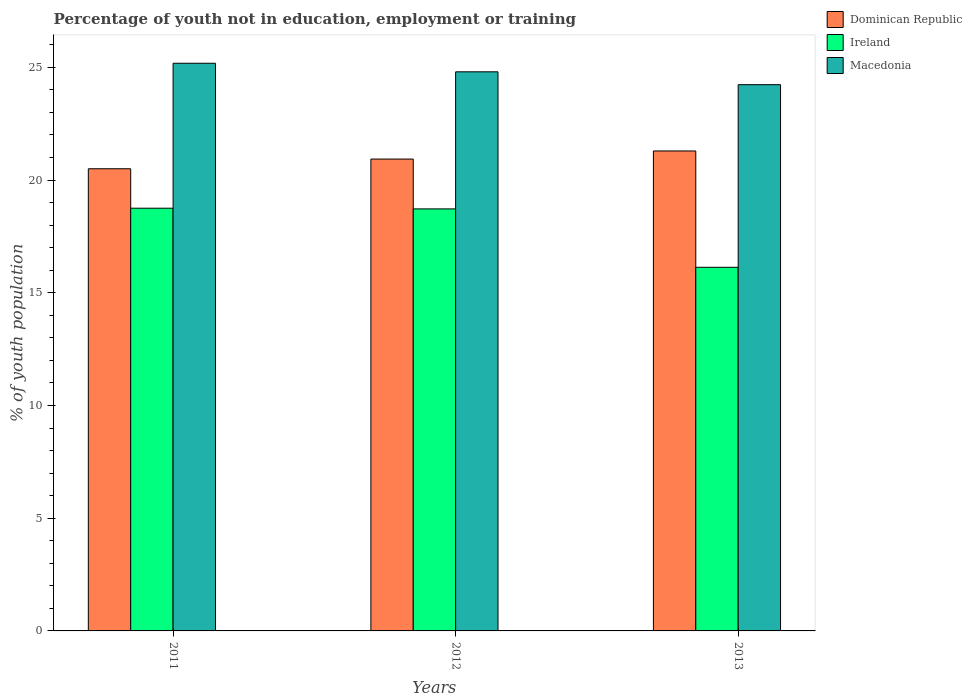How many different coloured bars are there?
Your answer should be very brief. 3. Are the number of bars per tick equal to the number of legend labels?
Give a very brief answer. Yes. Are the number of bars on each tick of the X-axis equal?
Offer a very short reply. Yes. How many bars are there on the 1st tick from the right?
Your answer should be very brief. 3. What is the label of the 1st group of bars from the left?
Offer a terse response. 2011. In how many cases, is the number of bars for a given year not equal to the number of legend labels?
Your answer should be very brief. 0. What is the percentage of unemployed youth population in in Ireland in 2013?
Provide a succinct answer. 16.13. Across all years, what is the maximum percentage of unemployed youth population in in Dominican Republic?
Give a very brief answer. 21.29. What is the total percentage of unemployed youth population in in Ireland in the graph?
Provide a short and direct response. 53.6. What is the difference between the percentage of unemployed youth population in in Ireland in 2012 and that in 2013?
Provide a succinct answer. 2.59. What is the difference between the percentage of unemployed youth population in in Ireland in 2011 and the percentage of unemployed youth population in in Dominican Republic in 2013?
Offer a very short reply. -2.54. What is the average percentage of unemployed youth population in in Ireland per year?
Offer a very short reply. 17.87. In the year 2012, what is the difference between the percentage of unemployed youth population in in Dominican Republic and percentage of unemployed youth population in in Macedonia?
Provide a short and direct response. -3.87. What is the ratio of the percentage of unemployed youth population in in Ireland in 2012 to that in 2013?
Ensure brevity in your answer.  1.16. Is the percentage of unemployed youth population in in Ireland in 2011 less than that in 2012?
Your response must be concise. No. What is the difference between the highest and the second highest percentage of unemployed youth population in in Macedonia?
Your answer should be compact. 0.38. What is the difference between the highest and the lowest percentage of unemployed youth population in in Macedonia?
Offer a terse response. 0.95. In how many years, is the percentage of unemployed youth population in in Dominican Republic greater than the average percentage of unemployed youth population in in Dominican Republic taken over all years?
Offer a terse response. 2. What does the 2nd bar from the left in 2011 represents?
Keep it short and to the point. Ireland. What does the 2nd bar from the right in 2013 represents?
Offer a terse response. Ireland. How many bars are there?
Offer a terse response. 9. Are the values on the major ticks of Y-axis written in scientific E-notation?
Your answer should be very brief. No. Does the graph contain any zero values?
Make the answer very short. No. Where does the legend appear in the graph?
Provide a succinct answer. Top right. What is the title of the graph?
Make the answer very short. Percentage of youth not in education, employment or training. What is the label or title of the Y-axis?
Give a very brief answer. % of youth population. What is the % of youth population in Dominican Republic in 2011?
Give a very brief answer. 20.5. What is the % of youth population in Ireland in 2011?
Make the answer very short. 18.75. What is the % of youth population of Macedonia in 2011?
Your answer should be very brief. 25.18. What is the % of youth population in Dominican Republic in 2012?
Provide a succinct answer. 20.93. What is the % of youth population in Ireland in 2012?
Keep it short and to the point. 18.72. What is the % of youth population in Macedonia in 2012?
Your answer should be very brief. 24.8. What is the % of youth population in Dominican Republic in 2013?
Make the answer very short. 21.29. What is the % of youth population of Ireland in 2013?
Offer a terse response. 16.13. What is the % of youth population in Macedonia in 2013?
Provide a short and direct response. 24.23. Across all years, what is the maximum % of youth population of Dominican Republic?
Provide a succinct answer. 21.29. Across all years, what is the maximum % of youth population in Ireland?
Keep it short and to the point. 18.75. Across all years, what is the maximum % of youth population in Macedonia?
Your answer should be very brief. 25.18. Across all years, what is the minimum % of youth population of Ireland?
Your answer should be very brief. 16.13. Across all years, what is the minimum % of youth population in Macedonia?
Your response must be concise. 24.23. What is the total % of youth population in Dominican Republic in the graph?
Your answer should be compact. 62.72. What is the total % of youth population in Ireland in the graph?
Give a very brief answer. 53.6. What is the total % of youth population of Macedonia in the graph?
Provide a short and direct response. 74.21. What is the difference between the % of youth population in Dominican Republic in 2011 and that in 2012?
Make the answer very short. -0.43. What is the difference between the % of youth population in Macedonia in 2011 and that in 2012?
Offer a very short reply. 0.38. What is the difference between the % of youth population of Dominican Republic in 2011 and that in 2013?
Keep it short and to the point. -0.79. What is the difference between the % of youth population in Ireland in 2011 and that in 2013?
Keep it short and to the point. 2.62. What is the difference between the % of youth population of Dominican Republic in 2012 and that in 2013?
Your response must be concise. -0.36. What is the difference between the % of youth population of Ireland in 2012 and that in 2013?
Your response must be concise. 2.59. What is the difference between the % of youth population of Macedonia in 2012 and that in 2013?
Provide a short and direct response. 0.57. What is the difference between the % of youth population of Dominican Republic in 2011 and the % of youth population of Ireland in 2012?
Your answer should be very brief. 1.78. What is the difference between the % of youth population of Ireland in 2011 and the % of youth population of Macedonia in 2012?
Offer a very short reply. -6.05. What is the difference between the % of youth population in Dominican Republic in 2011 and the % of youth population in Ireland in 2013?
Make the answer very short. 4.37. What is the difference between the % of youth population of Dominican Republic in 2011 and the % of youth population of Macedonia in 2013?
Provide a short and direct response. -3.73. What is the difference between the % of youth population in Ireland in 2011 and the % of youth population in Macedonia in 2013?
Provide a short and direct response. -5.48. What is the difference between the % of youth population in Dominican Republic in 2012 and the % of youth population in Ireland in 2013?
Offer a very short reply. 4.8. What is the difference between the % of youth population in Ireland in 2012 and the % of youth population in Macedonia in 2013?
Ensure brevity in your answer.  -5.51. What is the average % of youth population in Dominican Republic per year?
Keep it short and to the point. 20.91. What is the average % of youth population of Ireland per year?
Your response must be concise. 17.87. What is the average % of youth population of Macedonia per year?
Your response must be concise. 24.74. In the year 2011, what is the difference between the % of youth population of Dominican Republic and % of youth population of Macedonia?
Your answer should be very brief. -4.68. In the year 2011, what is the difference between the % of youth population in Ireland and % of youth population in Macedonia?
Your answer should be very brief. -6.43. In the year 2012, what is the difference between the % of youth population in Dominican Republic and % of youth population in Ireland?
Provide a succinct answer. 2.21. In the year 2012, what is the difference between the % of youth population in Dominican Republic and % of youth population in Macedonia?
Your answer should be compact. -3.87. In the year 2012, what is the difference between the % of youth population in Ireland and % of youth population in Macedonia?
Keep it short and to the point. -6.08. In the year 2013, what is the difference between the % of youth population of Dominican Republic and % of youth population of Ireland?
Provide a succinct answer. 5.16. In the year 2013, what is the difference between the % of youth population of Dominican Republic and % of youth population of Macedonia?
Make the answer very short. -2.94. What is the ratio of the % of youth population in Dominican Republic in 2011 to that in 2012?
Offer a terse response. 0.98. What is the ratio of the % of youth population in Ireland in 2011 to that in 2012?
Ensure brevity in your answer.  1. What is the ratio of the % of youth population of Macedonia in 2011 to that in 2012?
Keep it short and to the point. 1.02. What is the ratio of the % of youth population in Dominican Republic in 2011 to that in 2013?
Make the answer very short. 0.96. What is the ratio of the % of youth population of Ireland in 2011 to that in 2013?
Offer a very short reply. 1.16. What is the ratio of the % of youth population in Macedonia in 2011 to that in 2013?
Your response must be concise. 1.04. What is the ratio of the % of youth population in Dominican Republic in 2012 to that in 2013?
Your answer should be very brief. 0.98. What is the ratio of the % of youth population of Ireland in 2012 to that in 2013?
Give a very brief answer. 1.16. What is the ratio of the % of youth population in Macedonia in 2012 to that in 2013?
Make the answer very short. 1.02. What is the difference between the highest and the second highest % of youth population of Dominican Republic?
Your answer should be compact. 0.36. What is the difference between the highest and the second highest % of youth population of Ireland?
Give a very brief answer. 0.03. What is the difference between the highest and the second highest % of youth population in Macedonia?
Your answer should be very brief. 0.38. What is the difference between the highest and the lowest % of youth population in Dominican Republic?
Make the answer very short. 0.79. What is the difference between the highest and the lowest % of youth population in Ireland?
Provide a succinct answer. 2.62. What is the difference between the highest and the lowest % of youth population of Macedonia?
Offer a very short reply. 0.95. 